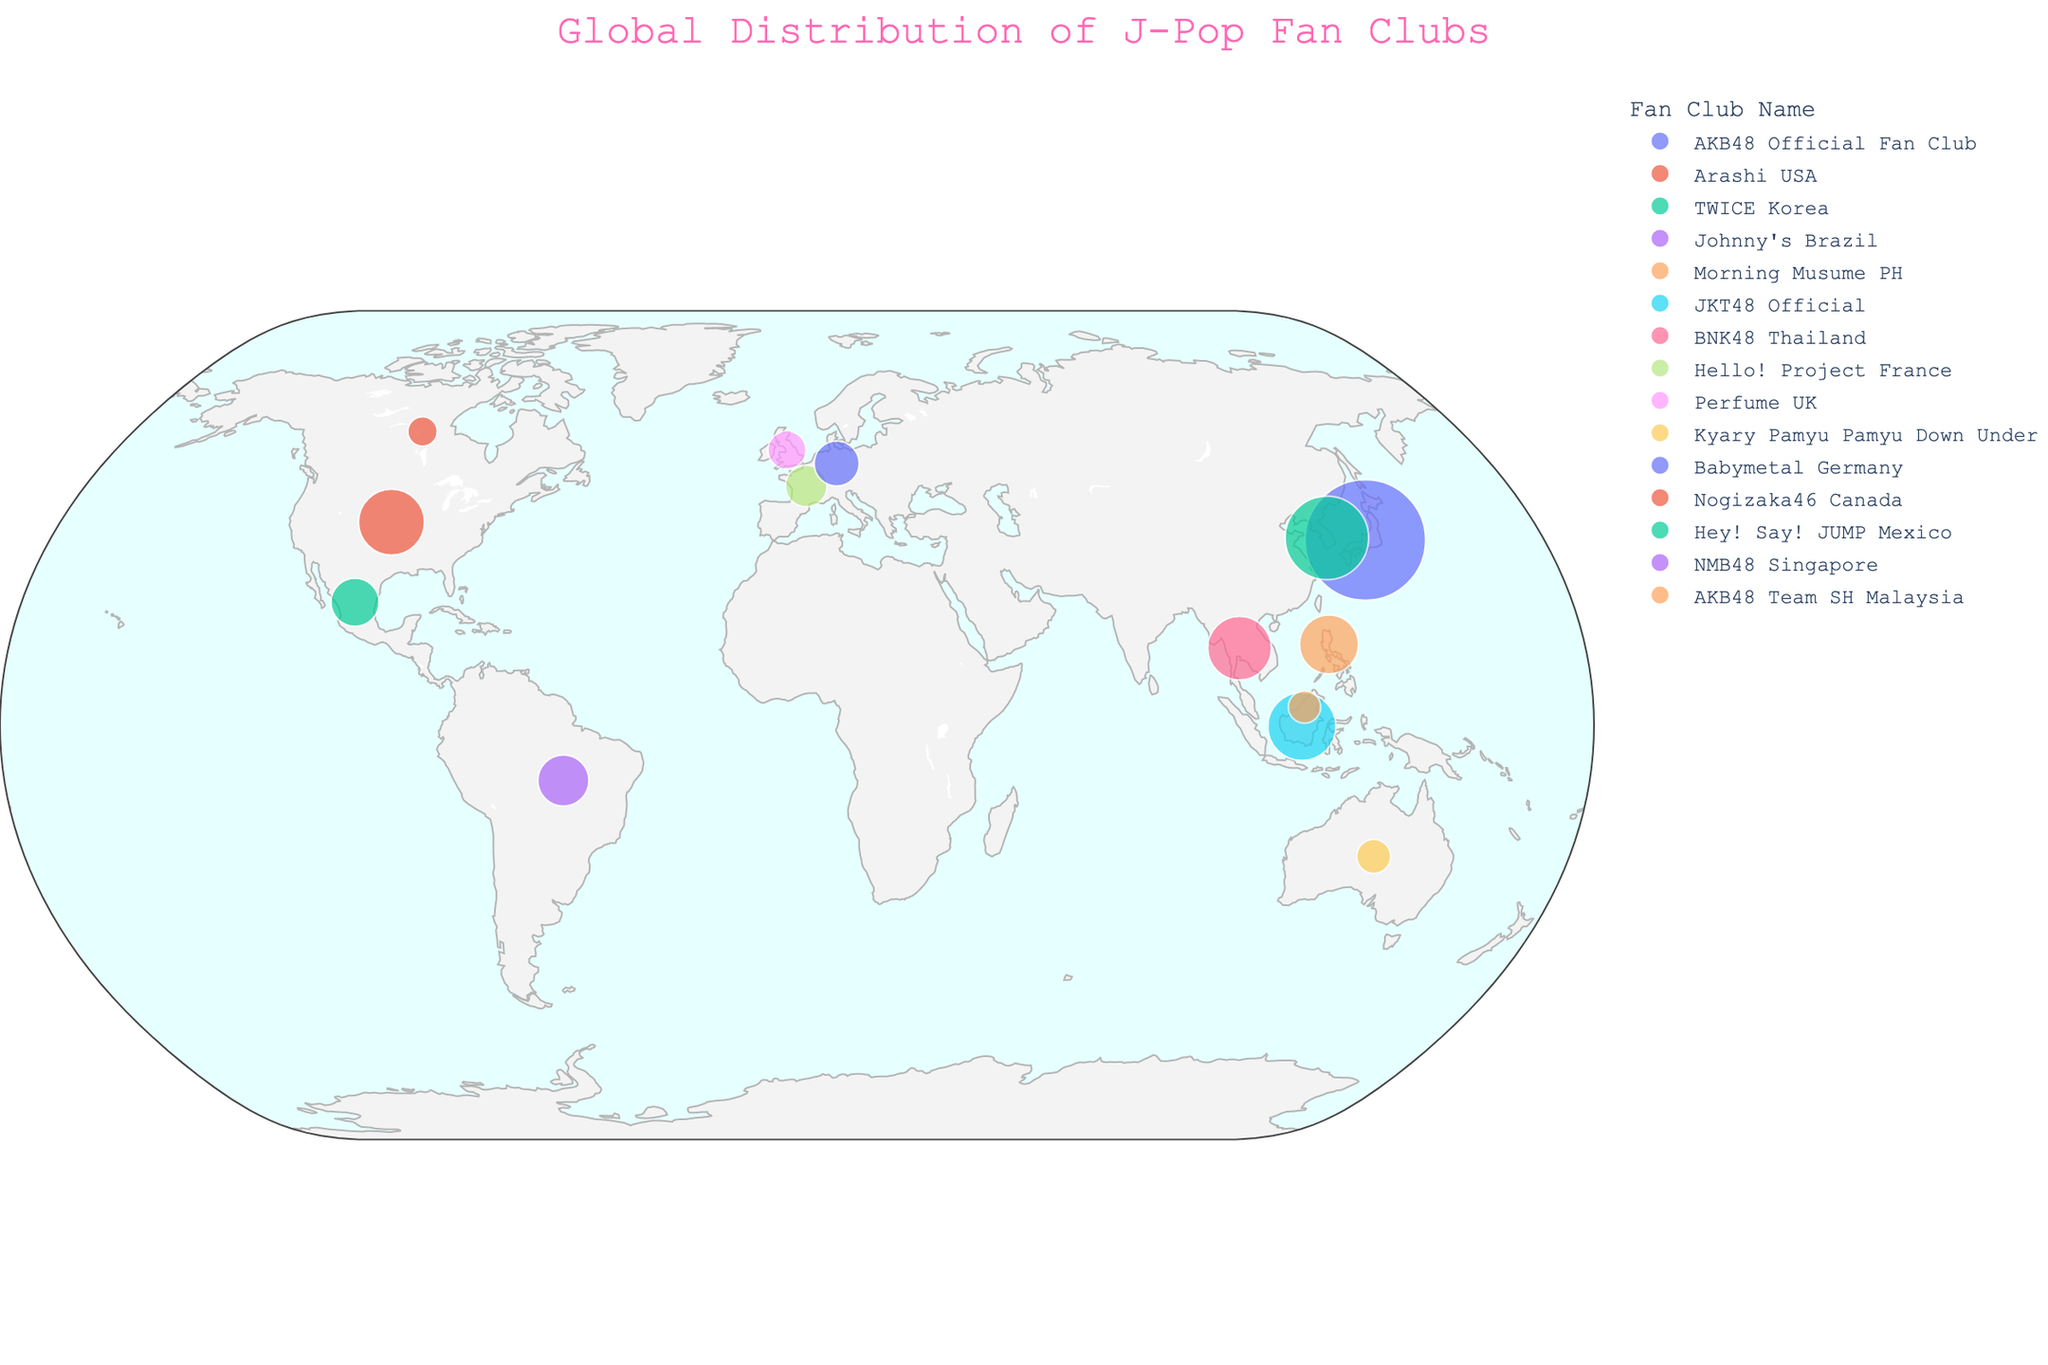Which city has the largest J-Pop fan club based on membership size? From the visual information, we can see that the largest point in terms of size on the geographic plot lies in Tokyo, Japan. Hovering over this point reveals it is the "AKB48 Official Fan Club" with a membership size of 250,000.
Answer: Tokyo What is the total membership size of J-Pop fan clubs in Southeast Asia (Philippines, Indonesia, Thailand, Malaysia, Singapore)? To find the total membership size in Southeast Asia, sum the membership sizes of clubs in Manila (60,000), Jakarta (80,000), Bangkok (70,000), Kuala Lumpur (18,000), and Singapore (22,000). Total = 60,000 + 80,000 + 70,000 + 18,000 + 22,000 = 250,000.
Answer: 250,000 Which country outside Asia has the highest membership size for a J-Pop fan club? By checking the points outside Asia, the largest membership size is found in Los Angeles, USA, with the "Arashi USA" fan club having 75,000 members.
Answer: USA How does the membership size of the "Johnny's Brazil" fan club compare to the "Babymetal Germany" fan club? Locate the points for Sao Paulo, Brazil, and Berlin, Germany. Sao Paulo's "Johnny's Brazil" fan club has 45,000 members, while Berlin's "Babymetal Germany" fan club has 35,000 members. 45,000 > 35,000, hence "Johnny's Brazil" has a larger membership size.
Answer: Johnny's Brazil is larger Which J-Pop fan club has the smallest membership? The smallest point on the geographic scatter plot is located in Sydney, Australia. Hovering over this point reveals the "Kyary Pamyu Pamyu Down Under" fan club with a membership size of 20,000.
Answer: Kyary Pamyu Pamyu Down Under Are there more J-Pop fan club members in Japan or in the rest of the world combined? The largest point in Japan represents the "AKB48 Official Fan Club" with 250,000 members. Summing up the membership sizes of fan clubs in the rest of the world: 75,000 (USA) + 120,000 (S. Korea) + 45,000 (Brazil) + 60,000 (Philippines) + 80,000 (Indonesia) + 70,000 (Thailand) + 30,000 (France) + 25,000 (UK) + 20,000 (Australia) + 35,000 (Germany) + 15,000 (Canada) + 40,000 (Mexico) + 22,000 (Singapore) + 18,000 (Malaysia) = 655,000. 655,000 > 250,000, therefore there are more members in the rest of the world combined.
Answer: More in the rest of the world What is the average membership size of J-Pop fan clubs in South America? There are two fan clubs in South America: "Johnny's Brazil" in Sao Paulo with 45,000 members and "Hey! Say! JUMP Mexico" in Mexico City (considering Mexico as part of Latin America) with 40,000 members. The average membership size is (45,000 + 40,000) / 2 = 42,500.
Answer: 42,500 Which two cities have fan clubs with exactly 60,000 and 50,000 or more membership sizes? From the plot, the cities with fan clubs having 60,000 and 50,000 or more members are Manila, Philippines (60,000) and Seoul, South Korea (120,000).
Answer: Manila and Seoul 